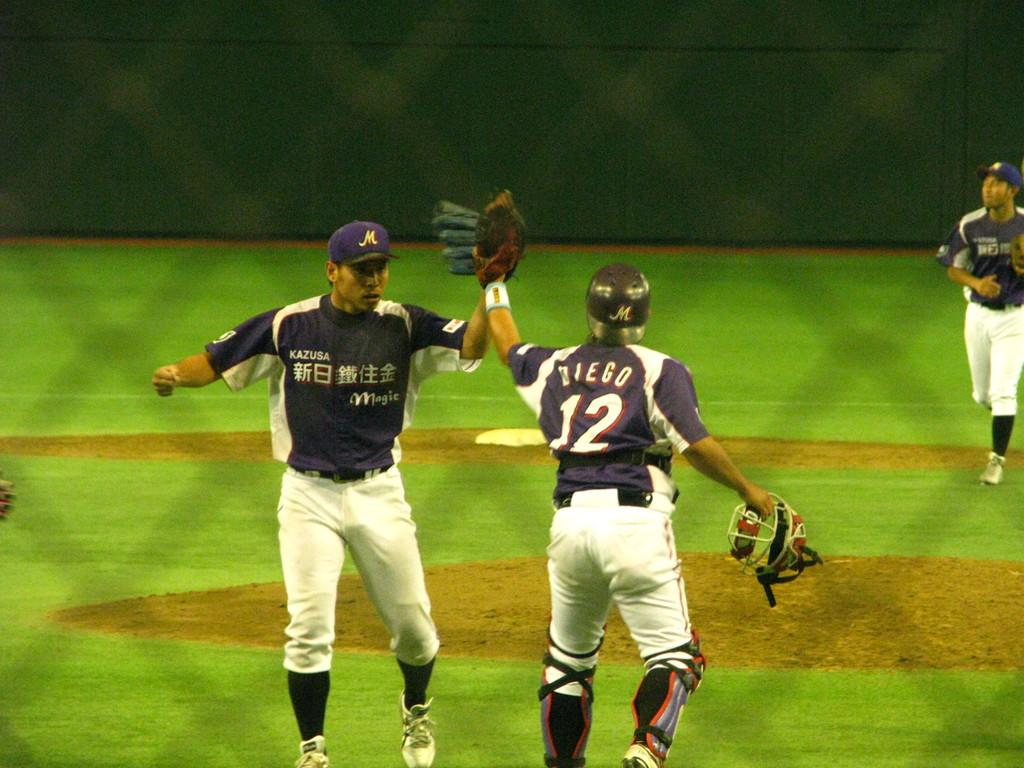<image>
Write a terse but informative summary of the picture. A pitcher with the number 12 on his back. 